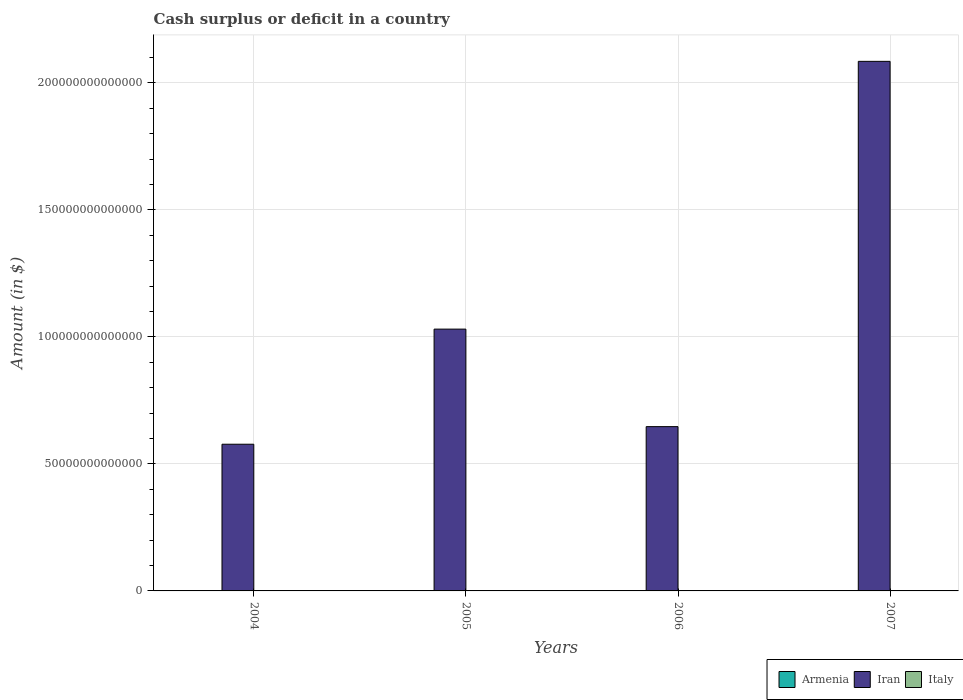How many different coloured bars are there?
Provide a short and direct response. 1. Are the number of bars per tick equal to the number of legend labels?
Your answer should be compact. No. What is the amount of cash surplus or deficit in Iran in 2005?
Offer a very short reply. 1.03e+14. Across all years, what is the maximum amount of cash surplus or deficit in Iran?
Keep it short and to the point. 2.08e+14. Across all years, what is the minimum amount of cash surplus or deficit in Iran?
Make the answer very short. 5.77e+13. In which year was the amount of cash surplus or deficit in Iran maximum?
Give a very brief answer. 2007. What is the total amount of cash surplus or deficit in Italy in the graph?
Keep it short and to the point. 0. What is the difference between the amount of cash surplus or deficit in Iran in 2005 and that in 2006?
Ensure brevity in your answer.  3.84e+13. What is the average amount of cash surplus or deficit in Italy per year?
Make the answer very short. 0. What is the ratio of the amount of cash surplus or deficit in Iran in 2005 to that in 2007?
Make the answer very short. 0.49. Is the amount of cash surplus or deficit in Iran in 2004 less than that in 2007?
Offer a very short reply. Yes. What is the difference between the highest and the lowest amount of cash surplus or deficit in Iran?
Give a very brief answer. 1.51e+14. In how many years, is the amount of cash surplus or deficit in Iran greater than the average amount of cash surplus or deficit in Iran taken over all years?
Provide a short and direct response. 1. Is the sum of the amount of cash surplus or deficit in Iran in 2006 and 2007 greater than the maximum amount of cash surplus or deficit in Armenia across all years?
Give a very brief answer. Yes. Is it the case that in every year, the sum of the amount of cash surplus or deficit in Italy and amount of cash surplus or deficit in Iran is greater than the amount of cash surplus or deficit in Armenia?
Keep it short and to the point. Yes. What is the difference between two consecutive major ticks on the Y-axis?
Your response must be concise. 5.00e+13. Does the graph contain any zero values?
Your answer should be compact. Yes. Does the graph contain grids?
Offer a terse response. Yes. How many legend labels are there?
Your answer should be compact. 3. What is the title of the graph?
Ensure brevity in your answer.  Cash surplus or deficit in a country. What is the label or title of the X-axis?
Your response must be concise. Years. What is the label or title of the Y-axis?
Offer a very short reply. Amount (in $). What is the Amount (in $) in Armenia in 2004?
Your answer should be compact. 0. What is the Amount (in $) of Iran in 2004?
Offer a very short reply. 5.77e+13. What is the Amount (in $) in Italy in 2004?
Your answer should be very brief. 0. What is the Amount (in $) of Iran in 2005?
Provide a short and direct response. 1.03e+14. What is the Amount (in $) in Italy in 2005?
Make the answer very short. 0. What is the Amount (in $) in Iran in 2006?
Provide a succinct answer. 6.47e+13. What is the Amount (in $) of Armenia in 2007?
Provide a short and direct response. 0. What is the Amount (in $) of Iran in 2007?
Provide a short and direct response. 2.08e+14. What is the Amount (in $) of Italy in 2007?
Provide a succinct answer. 0. Across all years, what is the maximum Amount (in $) of Iran?
Your answer should be compact. 2.08e+14. Across all years, what is the minimum Amount (in $) in Iran?
Keep it short and to the point. 5.77e+13. What is the total Amount (in $) of Iran in the graph?
Your answer should be compact. 4.34e+14. What is the total Amount (in $) of Italy in the graph?
Offer a very short reply. 0. What is the difference between the Amount (in $) of Iran in 2004 and that in 2005?
Make the answer very short. -4.53e+13. What is the difference between the Amount (in $) in Iran in 2004 and that in 2006?
Your answer should be compact. -6.92e+12. What is the difference between the Amount (in $) of Iran in 2004 and that in 2007?
Keep it short and to the point. -1.51e+14. What is the difference between the Amount (in $) of Iran in 2005 and that in 2006?
Provide a short and direct response. 3.84e+13. What is the difference between the Amount (in $) in Iran in 2005 and that in 2007?
Your answer should be very brief. -1.05e+14. What is the difference between the Amount (in $) in Iran in 2006 and that in 2007?
Make the answer very short. -1.44e+14. What is the average Amount (in $) of Armenia per year?
Provide a succinct answer. 0. What is the average Amount (in $) of Iran per year?
Provide a short and direct response. 1.08e+14. What is the ratio of the Amount (in $) in Iran in 2004 to that in 2005?
Your response must be concise. 0.56. What is the ratio of the Amount (in $) in Iran in 2004 to that in 2006?
Your response must be concise. 0.89. What is the ratio of the Amount (in $) in Iran in 2004 to that in 2007?
Offer a terse response. 0.28. What is the ratio of the Amount (in $) in Iran in 2005 to that in 2006?
Your answer should be compact. 1.59. What is the ratio of the Amount (in $) in Iran in 2005 to that in 2007?
Offer a terse response. 0.49. What is the ratio of the Amount (in $) of Iran in 2006 to that in 2007?
Keep it short and to the point. 0.31. What is the difference between the highest and the second highest Amount (in $) of Iran?
Your response must be concise. 1.05e+14. What is the difference between the highest and the lowest Amount (in $) of Iran?
Offer a very short reply. 1.51e+14. 